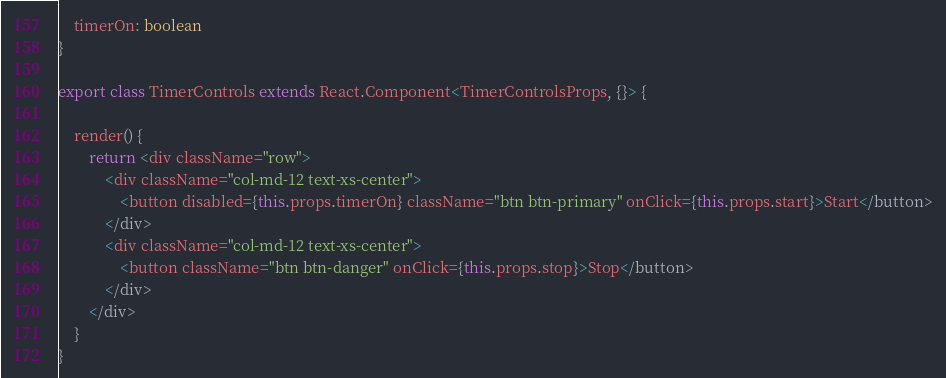Convert code to text. <code><loc_0><loc_0><loc_500><loc_500><_TypeScript_>    timerOn: boolean
}

export class TimerControls extends React.Component<TimerControlsProps, {}> {

    render() {
        return <div className="row">
            <div className="col-md-12 text-xs-center">
                <button disabled={this.props.timerOn} className="btn btn-primary" onClick={this.props.start}>Start</button>
            </div>
            <div className="col-md-12 text-xs-center">
                <button className="btn btn-danger" onClick={this.props.stop}>Stop</button>
            </div>
        </div>
    }
}</code> 